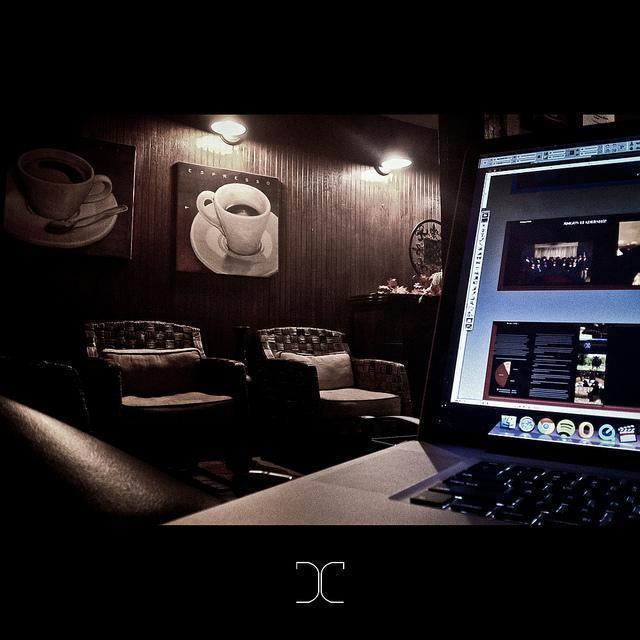What company is the main competitor to the laptop's operating system?
Pick the correct solution from the four options below to address the question.
Options: Microsoft, apple, samsung, android. Microsoft. 